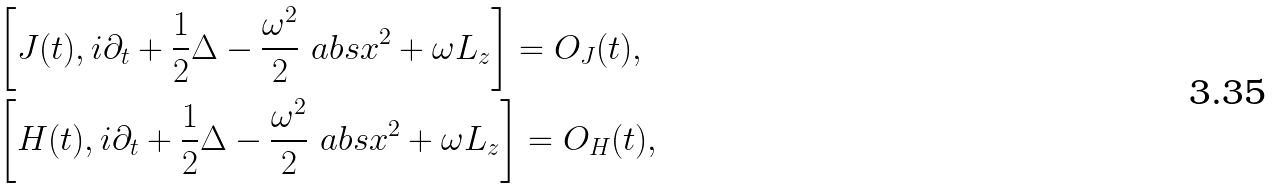<formula> <loc_0><loc_0><loc_500><loc_500>& \left [ J ( t ) , i \partial _ { t } + \frac { 1 } { 2 } \Delta - \frac { \omega ^ { 2 } } { 2 } \ a b s { x } ^ { 2 } + \omega L _ { z } \right ] = O _ { J } ( t ) , \\ & \left [ H ( t ) , i \partial _ { t } + \frac { 1 } { 2 } \Delta - \frac { \omega ^ { 2 } } { 2 } \ a b s { x } ^ { 2 } + \omega L _ { z } \right ] = O _ { H } ( t ) ,</formula> 